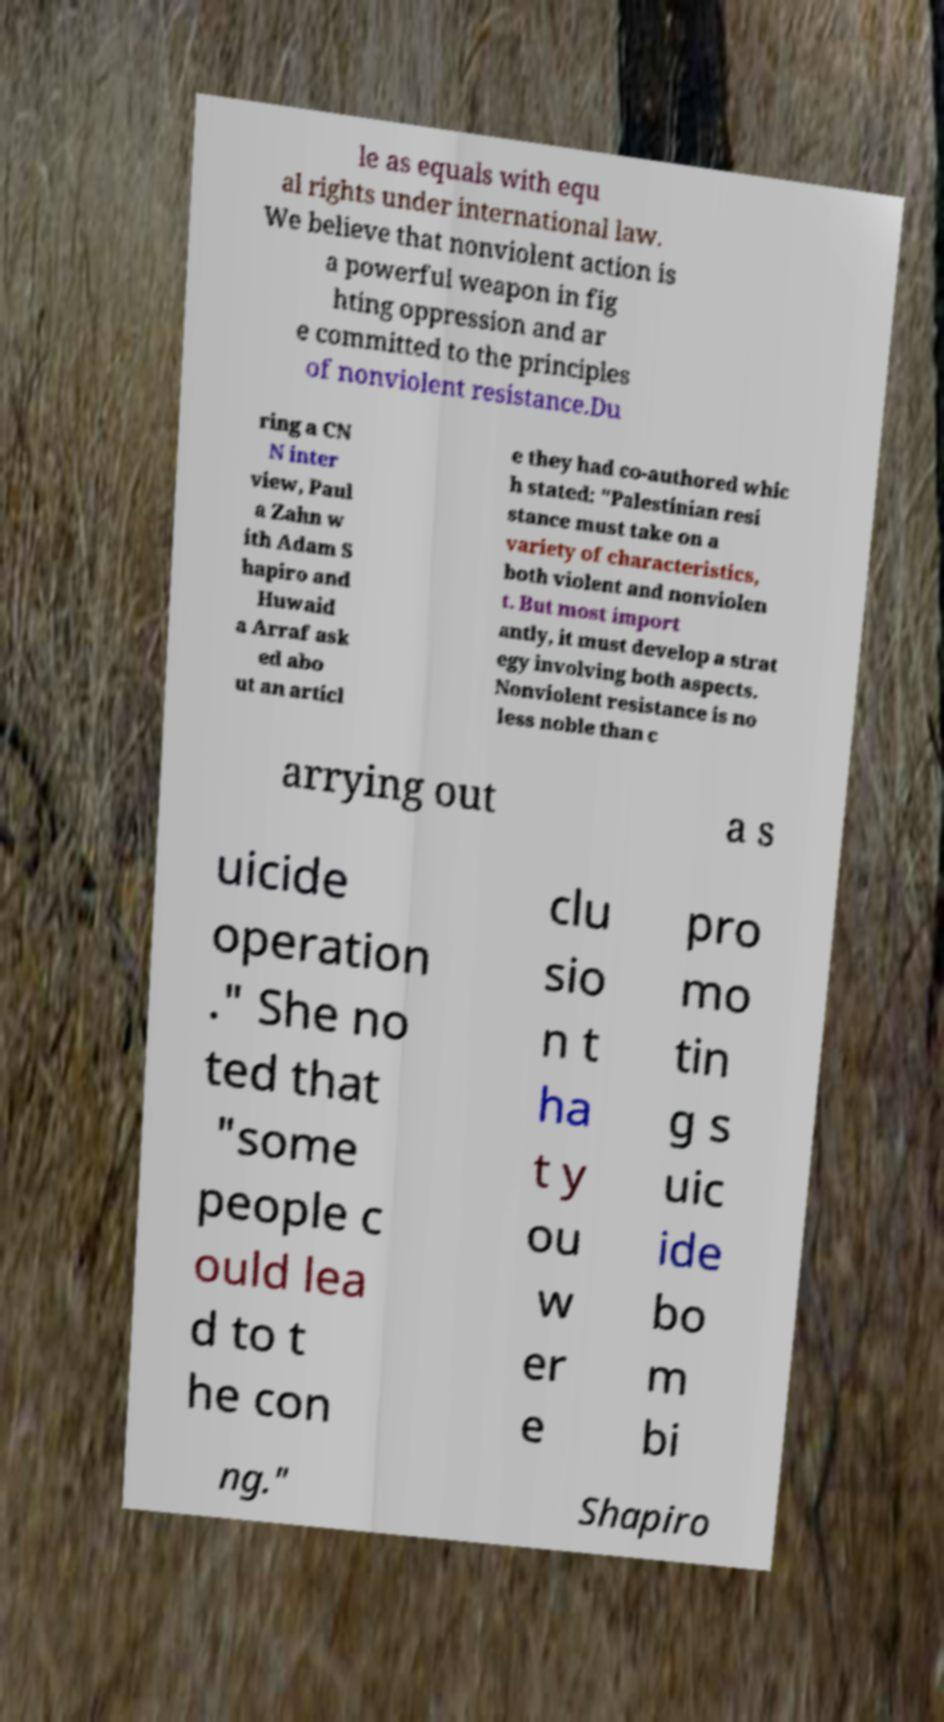What messages or text are displayed in this image? I need them in a readable, typed format. le as equals with equ al rights under international law. We believe that nonviolent action is a powerful weapon in fig hting oppression and ar e committed to the principles of nonviolent resistance.Du ring a CN N inter view, Paul a Zahn w ith Adam S hapiro and Huwaid a Arraf ask ed abo ut an articl e they had co-authored whic h stated: "Palestinian resi stance must take on a variety of characteristics, both violent and nonviolen t. But most import antly, it must develop a strat egy involving both aspects. Nonviolent resistance is no less noble than c arrying out a s uicide operation ." She no ted that "some people c ould lea d to t he con clu sio n t ha t y ou w er e pro mo tin g s uic ide bo m bi ng." Shapiro 